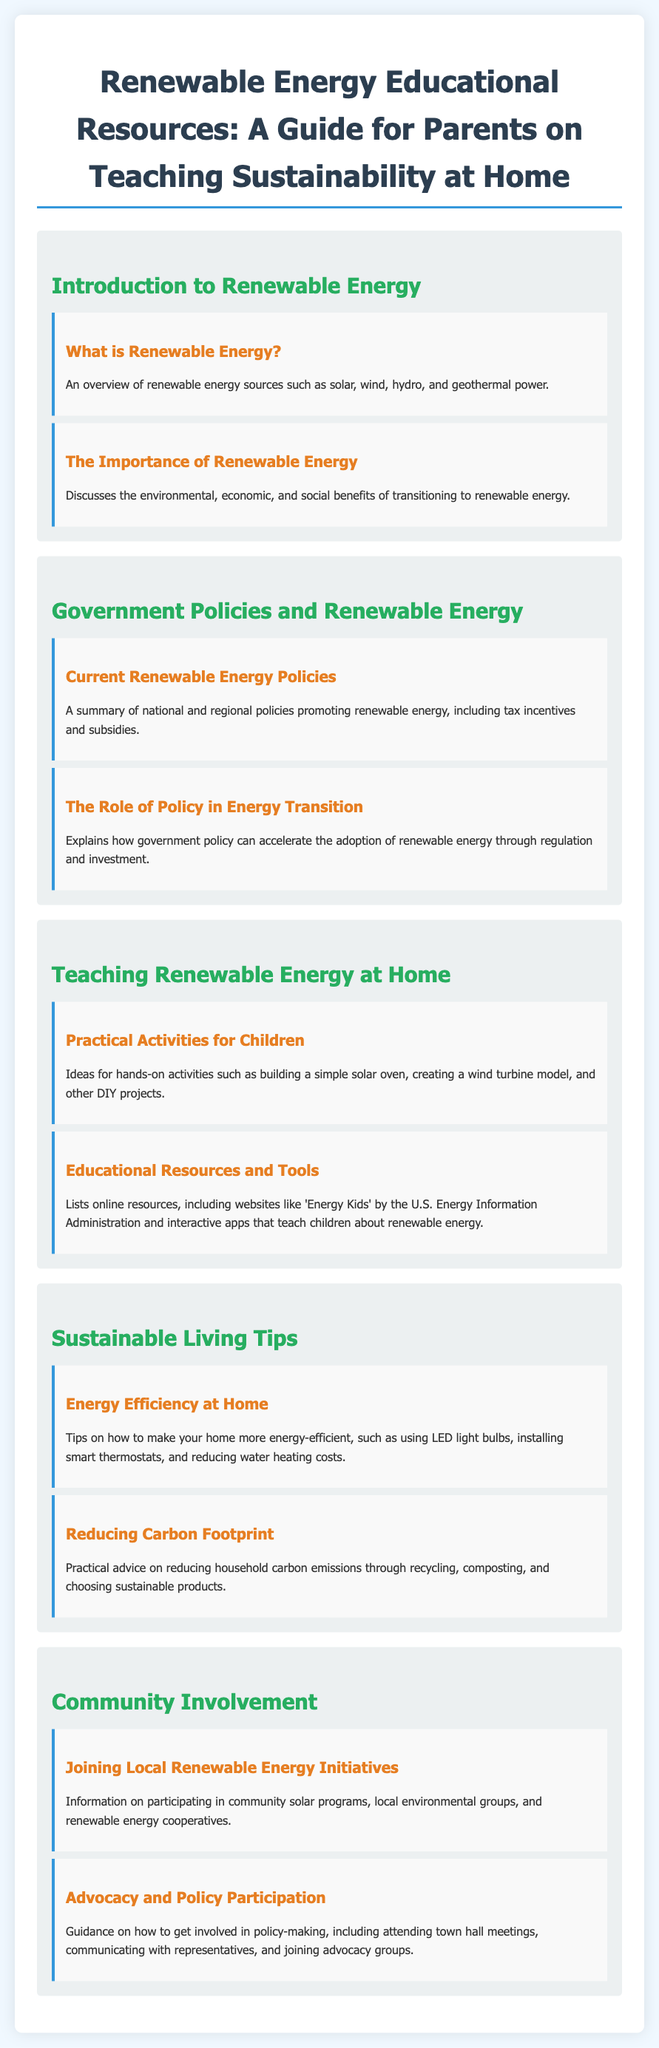What is renewable energy? The document defines renewable energy as sources like solar, wind, hydro, and geothermal power.
Answer: Solar, wind, hydro, geothermal What are the benefits of renewable energy? The document states that renewable energy has environmental, economic, and social benefits.
Answer: Environmental, economic, social What is a practical activity for children mentioned in the document? The document lists building a simple solar oven as a hands-on activity for kids.
Answer: Building a simple solar oven What are educational resources listed in the guide? The guide mentions online resources like 'Energy Kids' by the U.S. Energy Information Administration.
Answer: 'Energy Kids' What tips are provided for energy efficiency at home? The document suggests using LED light bulbs to make homes more energy-efficient.
Answer: Using LED light bulbs How can families reduce their carbon footprint? The document describes practical advice such as recycling and composting to lower carbon emissions.
Answer: Recycling, composting What community involvement is suggested in the guide? The document mentions participating in community solar programs as a way to get involved.
Answer: Community solar programs What type of involvement in policy-making is encouraged? The guide encourages attending town hall meetings as a way to engage in policy-making.
Answer: Attending town hall meetings 